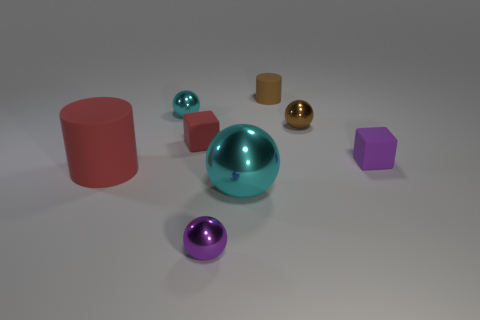There is a small ball to the left of the tiny purple shiny sphere; what is it made of?
Ensure brevity in your answer.  Metal. Is the number of brown cylinders that are behind the small cylinder the same as the number of big red cylinders?
Provide a short and direct response. No. Does the red cylinder have the same size as the brown metallic sphere?
Offer a terse response. No. There is a purple thing that is to the right of the cyan thing that is in front of the tiny cyan metal ball; are there any small metallic objects that are behind it?
Give a very brief answer. Yes. What is the material of the other object that is the same shape as the small purple rubber object?
Your answer should be very brief. Rubber. What number of small balls are behind the purple object that is behind the big red cylinder?
Provide a succinct answer. 2. There is a cyan thing right of the cyan metal ball to the left of the big thing that is to the right of the large rubber cylinder; what size is it?
Offer a very short reply. Large. The matte cylinder right of the cyan ball that is to the left of the big cyan metallic ball is what color?
Give a very brief answer. Brown. How many other things are there of the same material as the brown cylinder?
Your answer should be very brief. 3. How many other things are there of the same color as the big shiny sphere?
Provide a succinct answer. 1. 